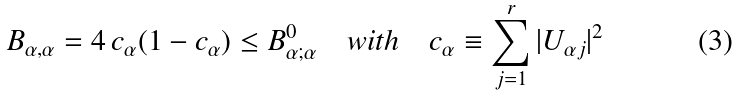<formula> <loc_0><loc_0><loc_500><loc_500>B _ { \alpha , \alpha } = 4 \, c _ { \alpha } ( 1 - c _ { \alpha } ) \leq B _ { \alpha ; \alpha } ^ { 0 } \quad w i t h \quad c _ { \alpha } \equiv \sum _ { j = 1 } ^ { r } | U _ { \alpha j } | ^ { 2 }</formula> 